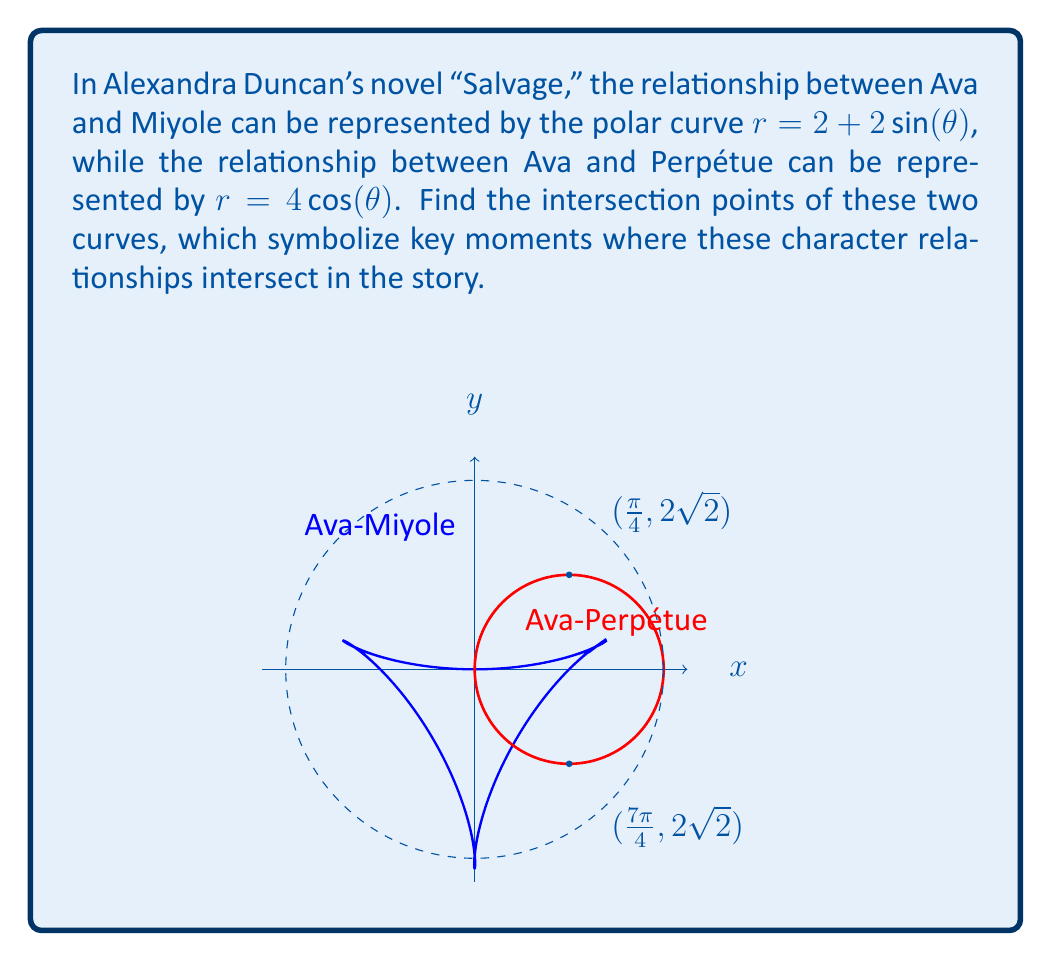Provide a solution to this math problem. To find the intersection points, we need to solve the equation:

$$ 2 + 2\sin(\theta) = 4\cos(\theta) $$

Step 1: Rearrange the equation
$$ 2\sin(\theta) + 4\cos(\theta) = 2 $$

Step 2: Divide both sides by 2
$$ \sin(\theta) + 2\cos(\theta) = 1 $$

Step 3: Use the substitution $\tan(\frac{\theta}{2}) = t$. This gives:
$$ \sin(\theta) = \frac{2t}{1+t^2}, \cos(\theta) = \frac{1-t^2}{1+t^2} $$

Step 4: Substitute these into our equation
$$ \frac{2t}{1+t^2} + 2(\frac{1-t^2}{1+t^2}) = 1 $$

Step 5: Simplify
$$ 2t + 2 - 2t^2 = 1 + t^2 $$
$$ 2t - 3t^2 + 1 = 0 $$

Step 6: Solve this quadratic equation
$$ t = 1 \text{ or } t = \frac{1}{3} $$

Step 7: Convert back to $\theta$ using $\theta = 2\arctan(t)$
$$ \theta = 2\arctan(1) = \frac{\pi}{2} \text{ or } \theta = 2\arctan(\frac{1}{3}) = \frac{\pi}{4} $$

Step 8: Due to symmetry, we also have solutions at $\theta = \frac{3\pi}{2}$ and $\theta = \frac{7\pi}{4}$

Step 9: Calculate $r$ for these $\theta$ values
For $\theta = \frac{\pi}{4}$ and $\frac{7\pi}{4}$: $r = 2 + 2\sin(\frac{\pi}{4}) = 2 + 2(\frac{\sqrt{2}}{2}) = 2\sqrt{2}$
For $\theta = \frac{\pi}{2}$ and $\frac{3\pi}{2}$: $r = 2 + 2\sin(\frac{\pi}{2}) = 4$, but $4\cos(\frac{\pi}{2}) = 0$, so these are not valid intersections.
Answer: $(\frac{\pi}{4}, 2\sqrt{2})$ and $(\frac{7\pi}{4}, 2\sqrt{2})$ 